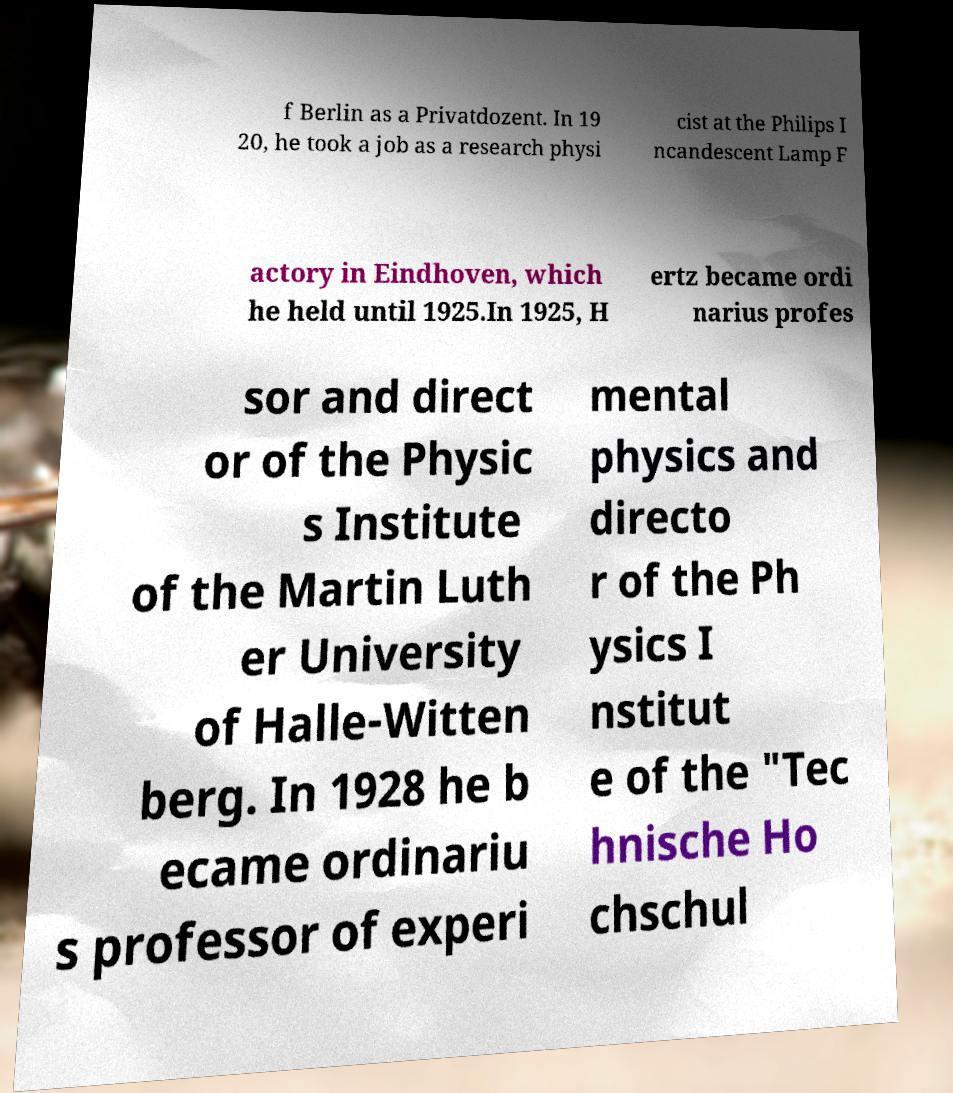Please identify and transcribe the text found in this image. f Berlin as a Privatdozent. In 19 20, he took a job as a research physi cist at the Philips I ncandescent Lamp F actory in Eindhoven, which he held until 1925.In 1925, H ertz became ordi narius profes sor and direct or of the Physic s Institute of the Martin Luth er University of Halle-Witten berg. In 1928 he b ecame ordinariu s professor of experi mental physics and directo r of the Ph ysics I nstitut e of the "Tec hnische Ho chschul 